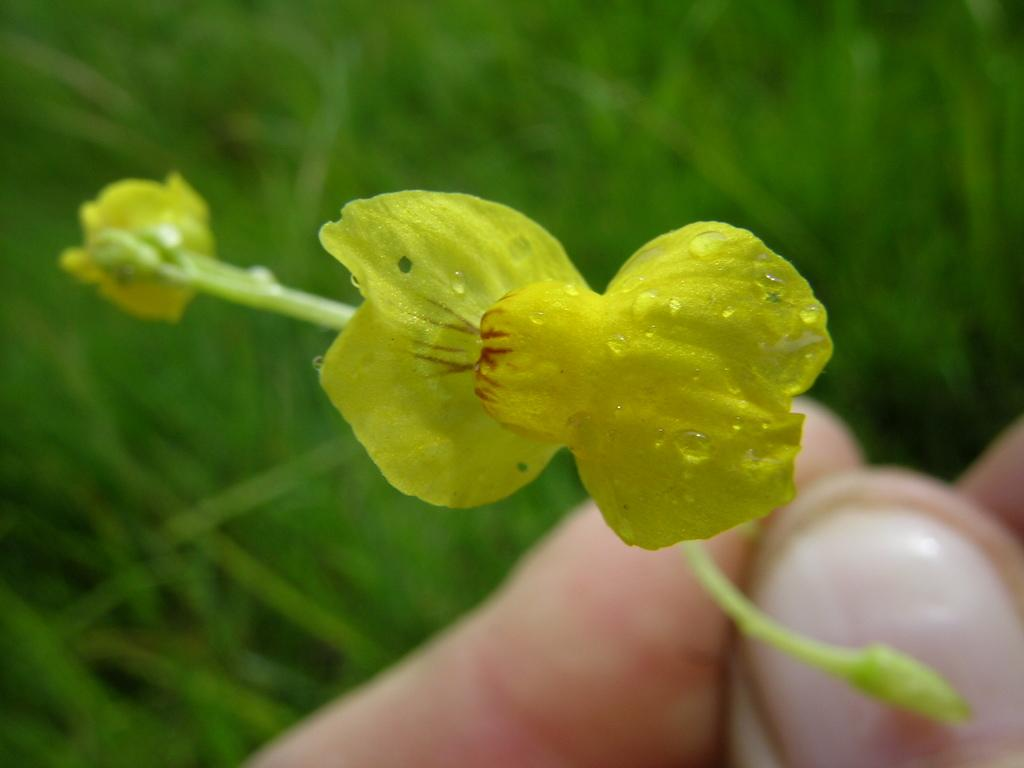What is the person holding in the image? There is a person's hand holding a small sapling in the image. What can be observed about the sapling? The sapling has yellow flowers. What type of vegetation is visible in the background of the image? There is green grass in the background of the image. How many houses can be seen in the image? There are no houses visible in the image; it features a person's hand holding a small sapling with yellow flowers and green grass in the background. What type of stem is present in the image? There is no specific stem mentioned or visible in the image; it features a small sapling with yellow flowers. 